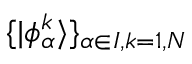<formula> <loc_0><loc_0><loc_500><loc_500>\{ | \phi _ { \alpha } ^ { k } \rangle \} _ { \alpha \in I , k = 1 , N }</formula> 